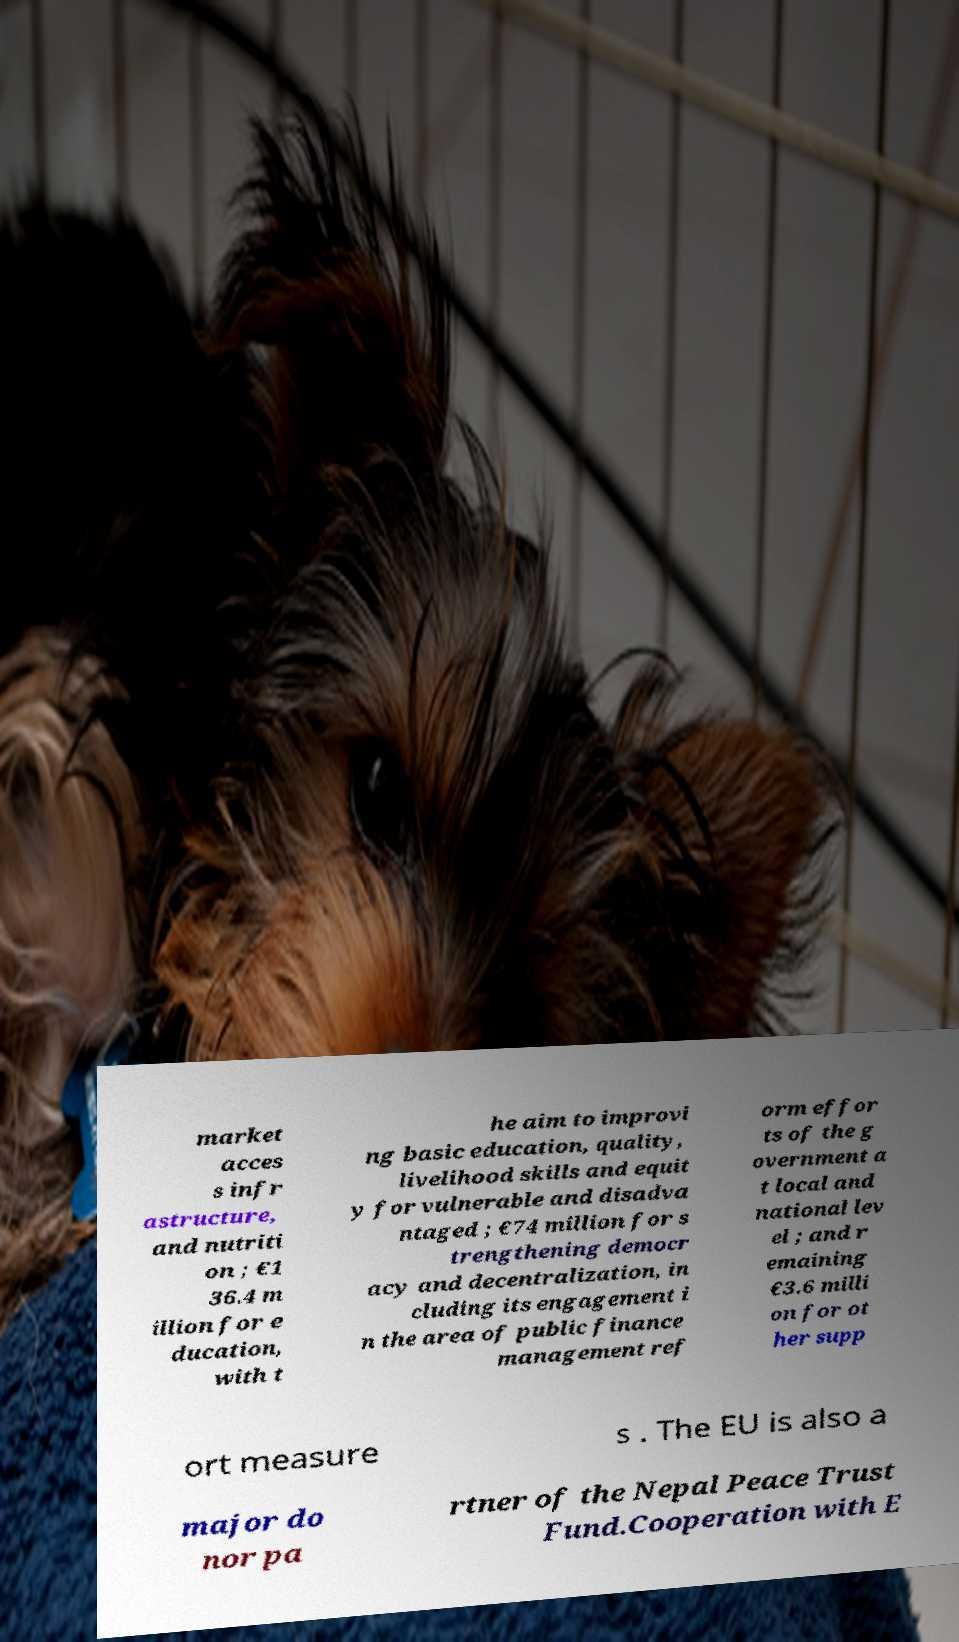What messages or text are displayed in this image? I need them in a readable, typed format. market acces s infr astructure, and nutriti on ; €1 36.4 m illion for e ducation, with t he aim to improvi ng basic education, quality, livelihood skills and equit y for vulnerable and disadva ntaged ; €74 million for s trengthening democr acy and decentralization, in cluding its engagement i n the area of public finance management ref orm effor ts of the g overnment a t local and national lev el ; and r emaining €3.6 milli on for ot her supp ort measure s . The EU is also a major do nor pa rtner of the Nepal Peace Trust Fund.Cooperation with E 